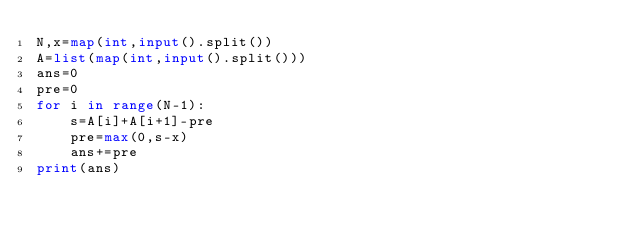<code> <loc_0><loc_0><loc_500><loc_500><_Python_>N,x=map(int,input().split())
A=list(map(int,input().split()))
ans=0
pre=0
for i in range(N-1):
    s=A[i]+A[i+1]-pre
    pre=max(0,s-x)
    ans+=pre
print(ans)</code> 